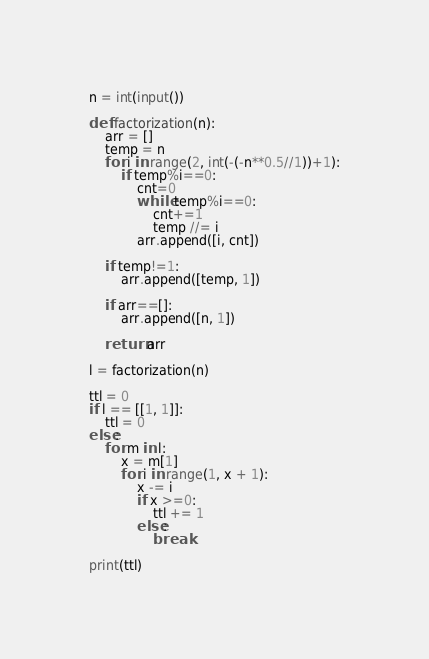<code> <loc_0><loc_0><loc_500><loc_500><_Python_>n = int(input())

def factorization(n):
    arr = []
    temp = n
    for i in range(2, int(-(-n**0.5//1))+1):
        if temp%i==0:
            cnt=0
            while temp%i==0:
                cnt+=1
                temp //= i
            arr.append([i, cnt])

    if temp!=1:
        arr.append([temp, 1])

    if arr==[]:
        arr.append([n, 1])

    return arr

l = factorization(n)

ttl = 0
if l == [[1, 1]]:
    ttl = 0
else:
    for m in l:
        x = m[1]
        for i in range(1, x + 1):
            x -= i
            if x >=0:
                ttl += 1
            else:
                break

print(ttl)</code> 